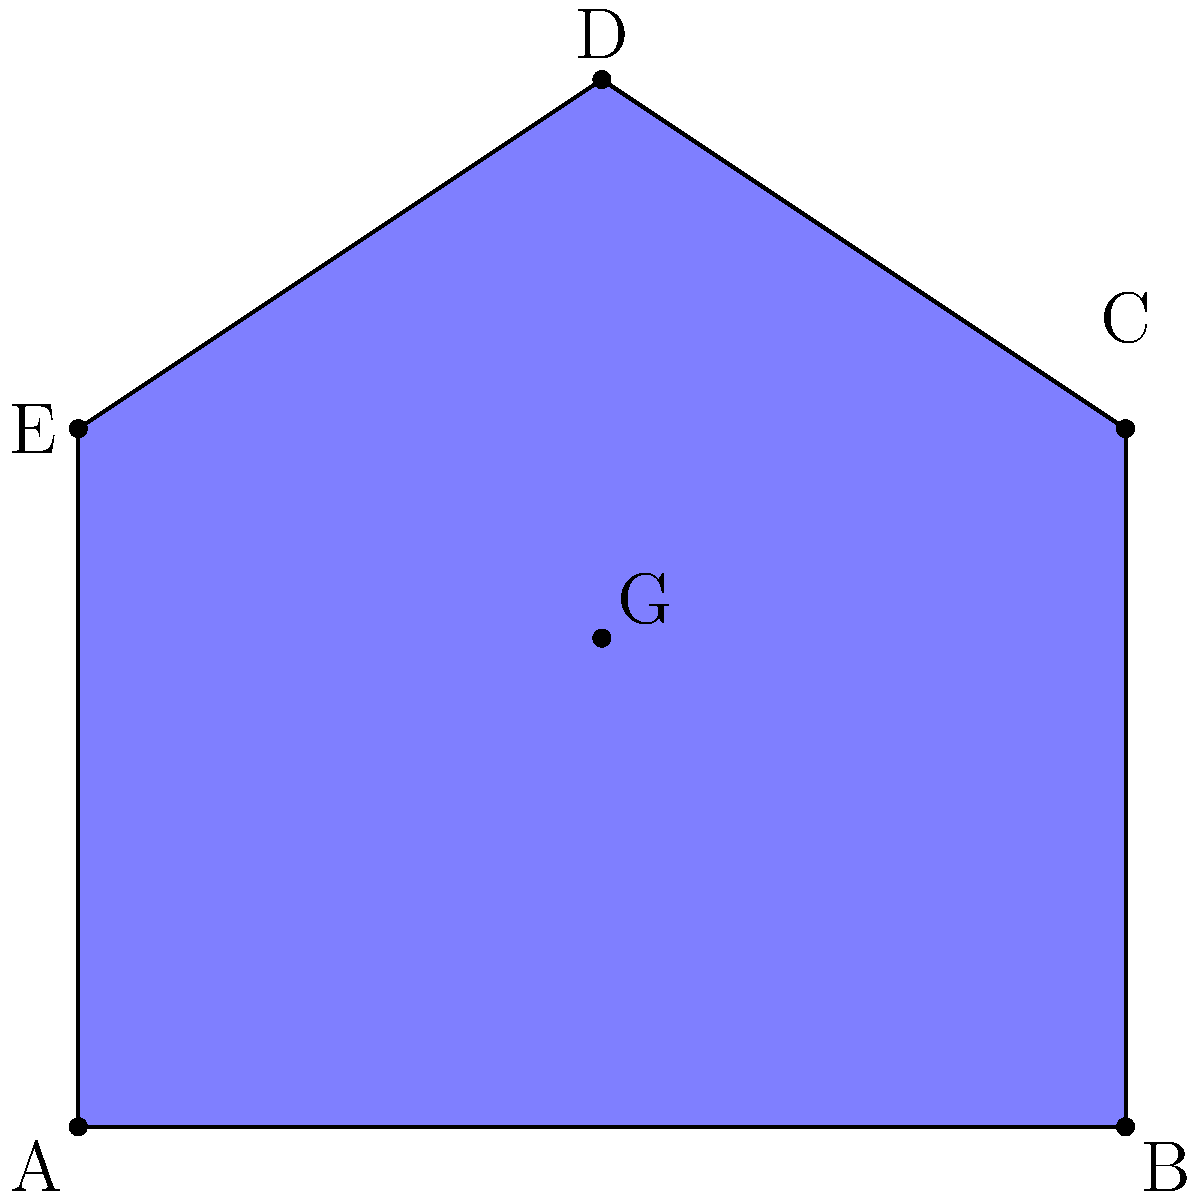In a hypothetical scenario, five allied nations form a strategic partnership represented by the pentagon ABCDE. If each vertex represents the capital city of a nation, where should the coalition's central command be located to minimize travel distances? Assume the region is on a flat plane and distances are Euclidean. To find the optimal location for the central command, we need to determine the centroid of the pentagon. The centroid minimizes the sum of squared distances to all vertices, making it ideal for minimizing travel times. Here's how to calculate it:

1. The centroid of a polygon is the arithmetic mean of all its vertices.

2. For a pentagon with vertices $(x_1, y_1)$, $(x_2, y_2)$, $(x_3, y_3)$, $(x_4, y_4)$, and $(x_5, y_5)$, the centroid $(x_G, y_G)$ is calculated as:

   $$x_G = \frac{x_1 + x_2 + x_3 + x_4 + x_5}{5}$$
   $$y_G = \frac{y_1 + y_2 + y_3 + y_4 + y_5}{5}$$

3. In this case, the coordinates of the vertices are:
   A(0,0), B(6,0), C(6,4), D(3,6), E(0,4)

4. Applying the formulas:
   $$x_G = \frac{0 + 6 + 6 + 3 + 0}{5} = \frac{15}{5} = 3$$
   $$y_G = \frac{0 + 0 + 4 + 6 + 4}{5} = \frac{14}{5} = 2.8$$

5. Therefore, the centroid G is located at (3, 2.8).

This point G represents the optimal location for the central command, as it minimizes the overall distance to all capital cities, assuming equal importance of each nation in the coalition.
Answer: (3, 2.8) 